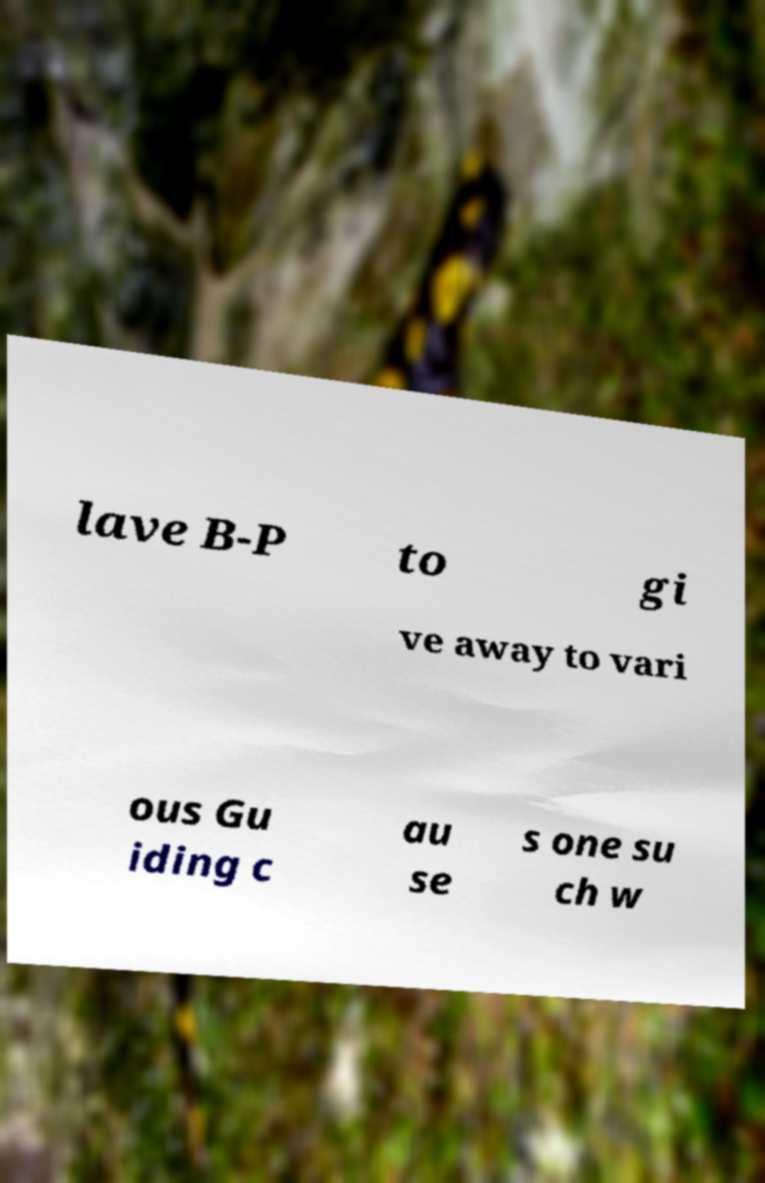There's text embedded in this image that I need extracted. Can you transcribe it verbatim? lave B-P to gi ve away to vari ous Gu iding c au se s one su ch w 